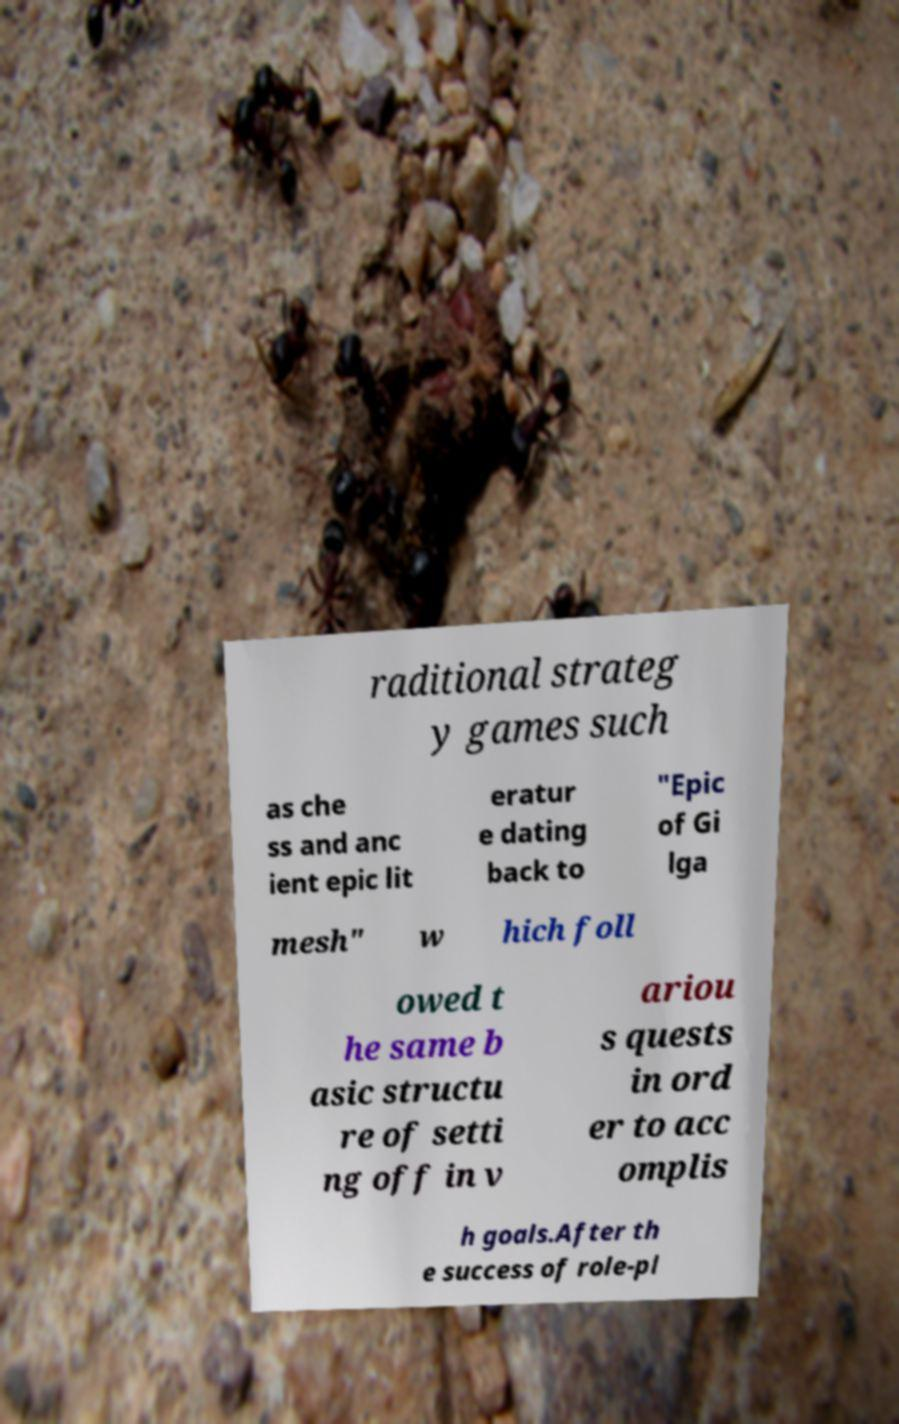Please identify and transcribe the text found in this image. raditional strateg y games such as che ss and anc ient epic lit eratur e dating back to "Epic of Gi lga mesh" w hich foll owed t he same b asic structu re of setti ng off in v ariou s quests in ord er to acc omplis h goals.After th e success of role-pl 